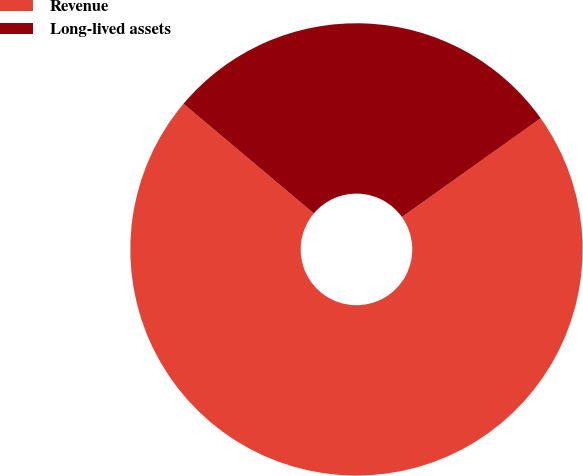<chart> <loc_0><loc_0><loc_500><loc_500><pie_chart><fcel>Revenue<fcel>Long-lived assets<nl><fcel>70.98%<fcel>29.02%<nl></chart> 